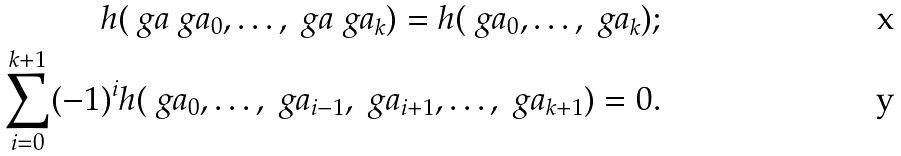<formula> <loc_0><loc_0><loc_500><loc_500>h ( \ g a \ g a _ { 0 } , \dots , \ g a \ g a _ { k } ) = h ( \ g a _ { 0 } , \dots , \ g a _ { k } ) ; \\ \sum _ { i = 0 } ^ { k + 1 } ( - 1 ) ^ { i } h ( \ g a _ { 0 } , \dots , \ g a _ { i - 1 } , \ g a _ { i + 1 } , \dots , \ g a _ { k + 1 } ) = 0 .</formula> 